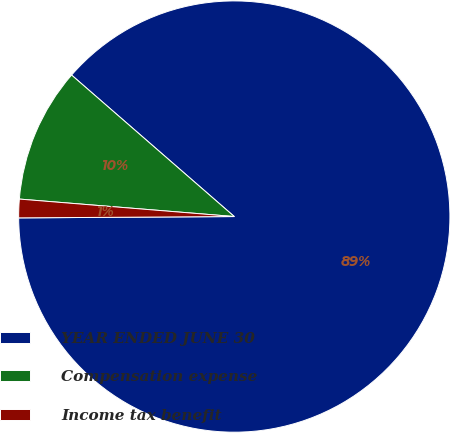<chart> <loc_0><loc_0><loc_500><loc_500><pie_chart><fcel>YEAR ENDED JUNE 30<fcel>Compensation expense<fcel>Income tax benefit<nl><fcel>88.51%<fcel>10.1%<fcel>1.39%<nl></chart> 